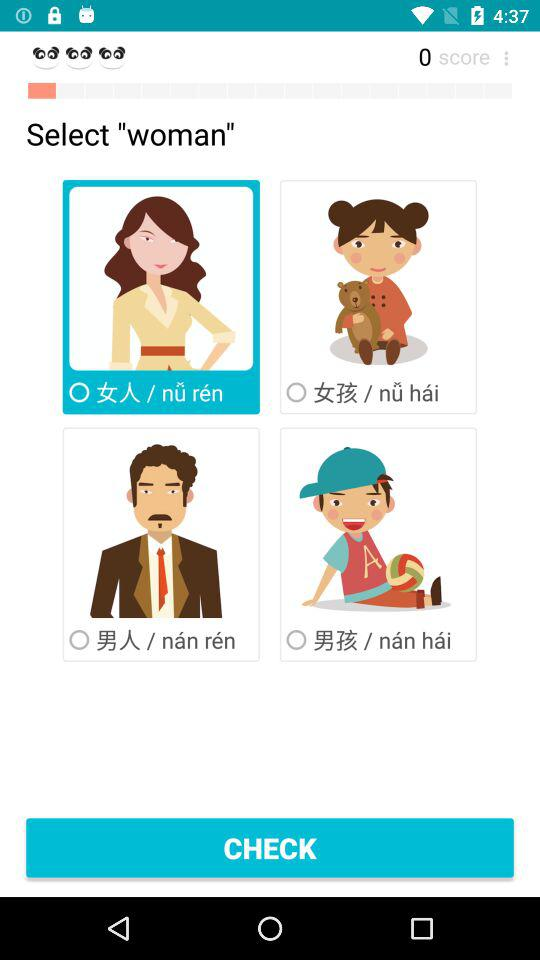What is the score? The score is 0. 